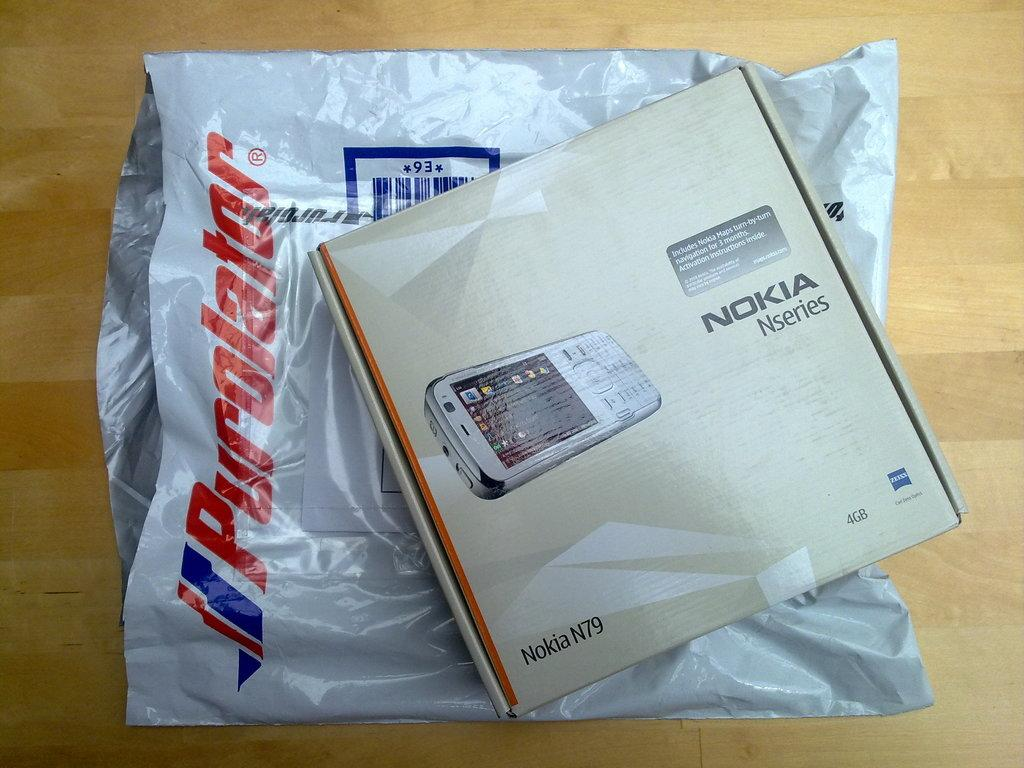<image>
Provide a brief description of the given image. A box that has the word Nokia Nseries written on it for a cell phone. 